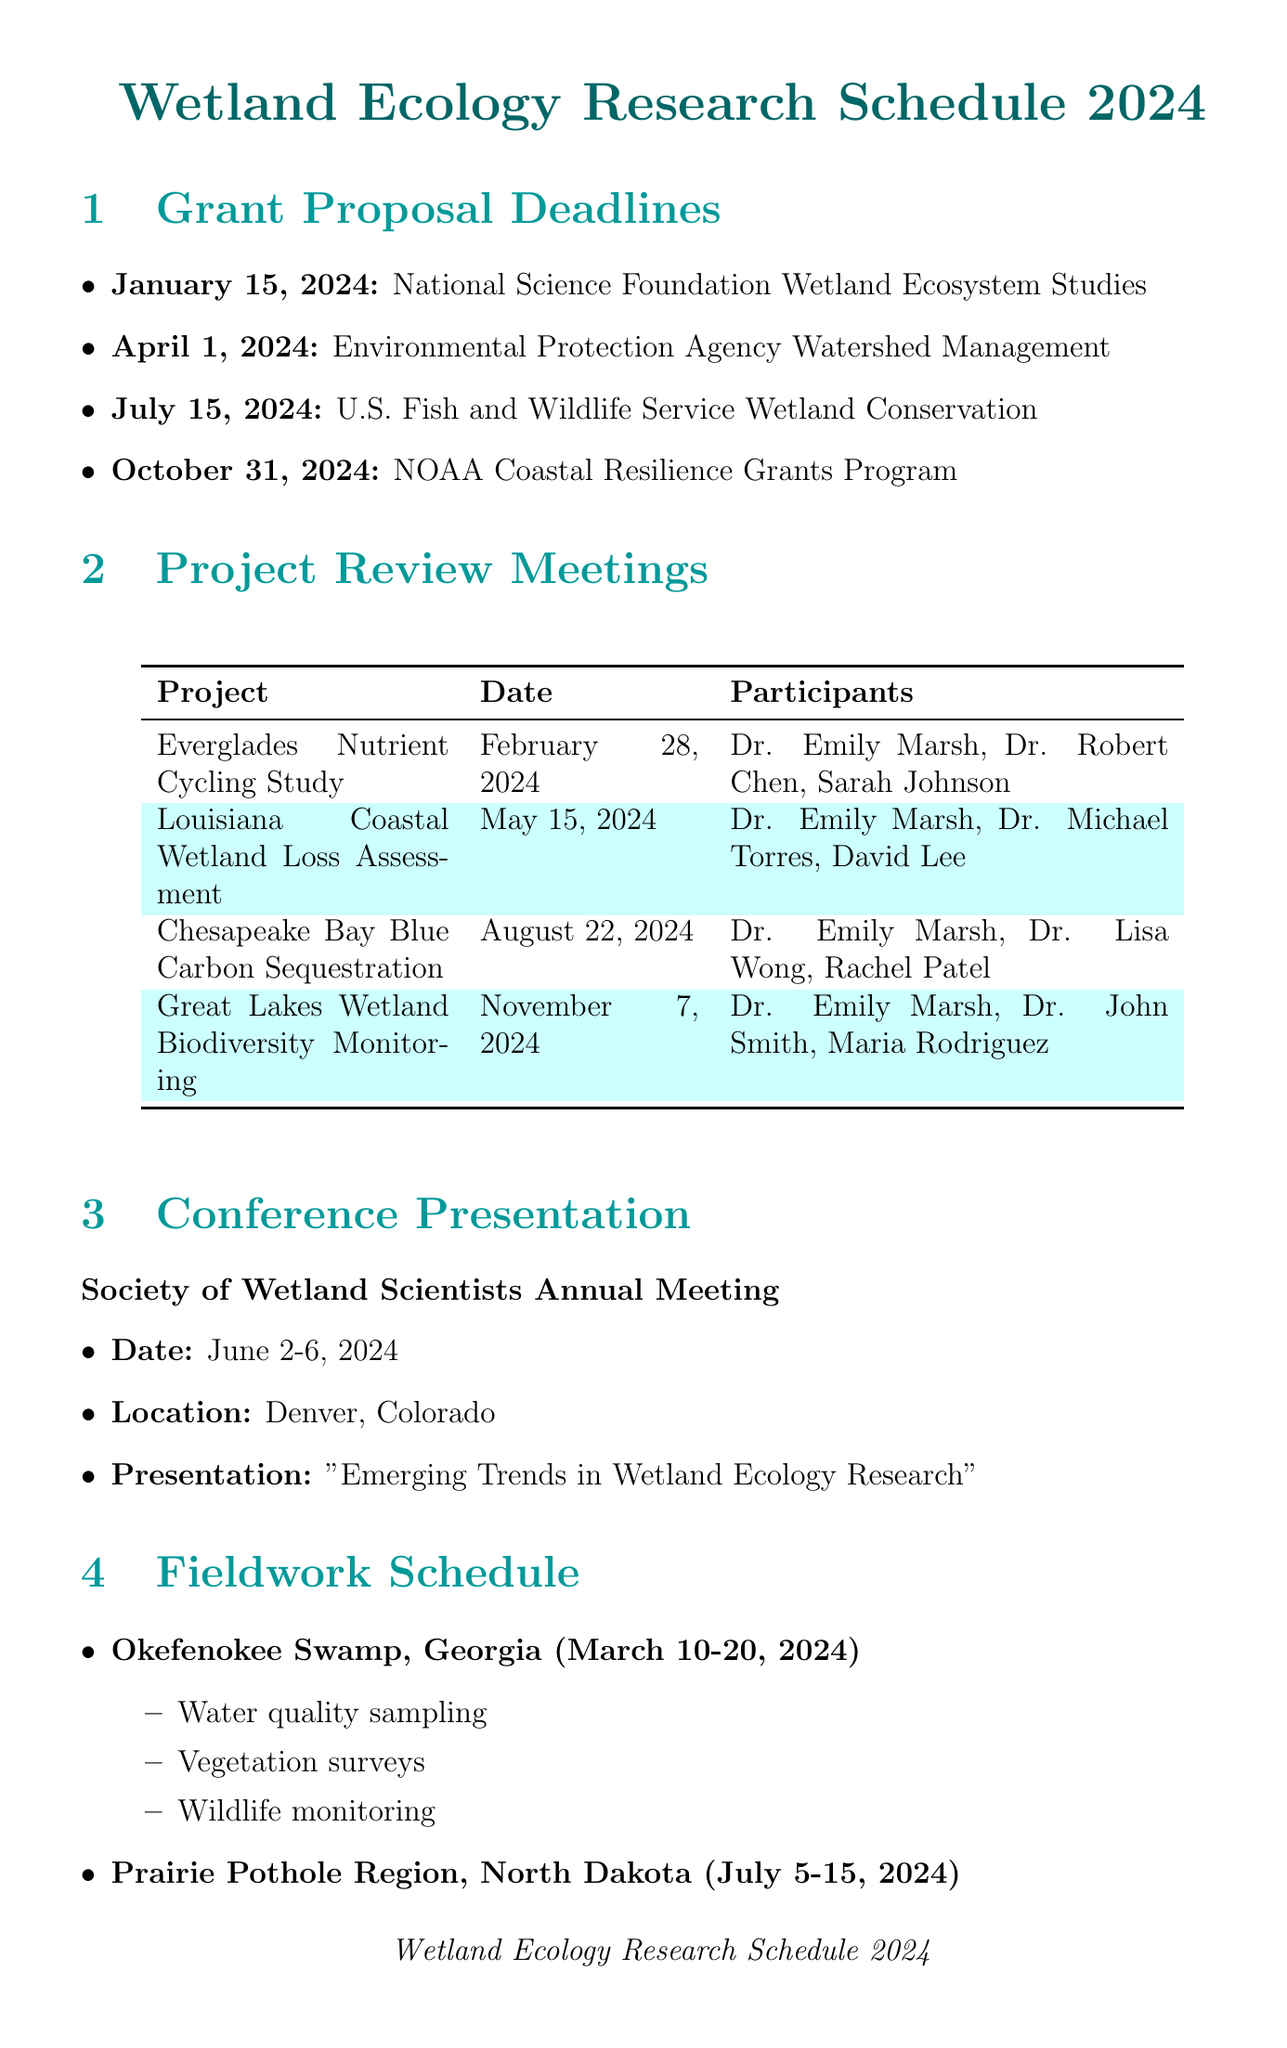what is the deadline for the National Science Foundation Wetland Ecosystem Studies grant? The document lists the specific grant deadline for this proposal as January 15, 2024.
Answer: January 15, 2024 who are the participants in the Everglades Nutrient Cycling Study review meeting? The document specifies the participants for this project as Dr. Emily Marsh, Dr. Robert Chen, and Ph.D. candidate Sarah Johnson.
Answer: Dr. Emily Marsh, Dr. Robert Chen, Sarah Johnson what is the focus of the U.S. Fish and Wildlife Service Wetland Conservation grant? This grant focuses on habitat preservation for migratory birds in wetlands, as mentioned in the document.
Answer: Habitat preservation for migratory birds in wetlands when is the Society of Wetland Scientists Annual Meeting scheduled? The document indicates the dates for this conference are June 2-6, 2024.
Answer: June 2-6, 2024 how many project review meetings are listed in the document? The document includes a total of four project review meetings.
Answer: Four which location is fieldwork scheduled for from March 10-20, 2024? The document indicates that fieldwork will take place in Okefenokee Swamp, Georgia during these dates.
Answer: Okefenokee Swamp, Georgia which journal has a submission deadline of September 1, 2024? The document mentions that the journal Wetlands has this specific submission deadline.
Answer: Wetlands what is the proposed activity during the fieldwork in the Prairie Pothole Region? The document lists multiple activities including soil core collection, greenhouse gas flux measurements, and hydrological assessments.
Answer: Soil core collection, greenhouse gas flux measurements, hydrological assessments 